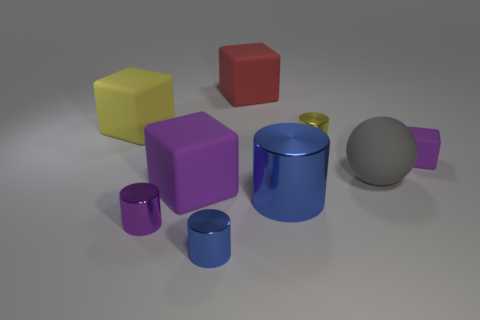Subtract all yellow metal cylinders. How many cylinders are left? 3 Subtract 1 blocks. How many blocks are left? 3 Subtract all brown cylinders. Subtract all red cubes. How many cylinders are left? 4 Add 1 large blue shiny things. How many objects exist? 10 Subtract all spheres. How many objects are left? 8 Add 3 rubber objects. How many rubber objects exist? 8 Subtract 1 yellow cubes. How many objects are left? 8 Subtract all purple cylinders. Subtract all big objects. How many objects are left? 3 Add 2 tiny purple cylinders. How many tiny purple cylinders are left? 3 